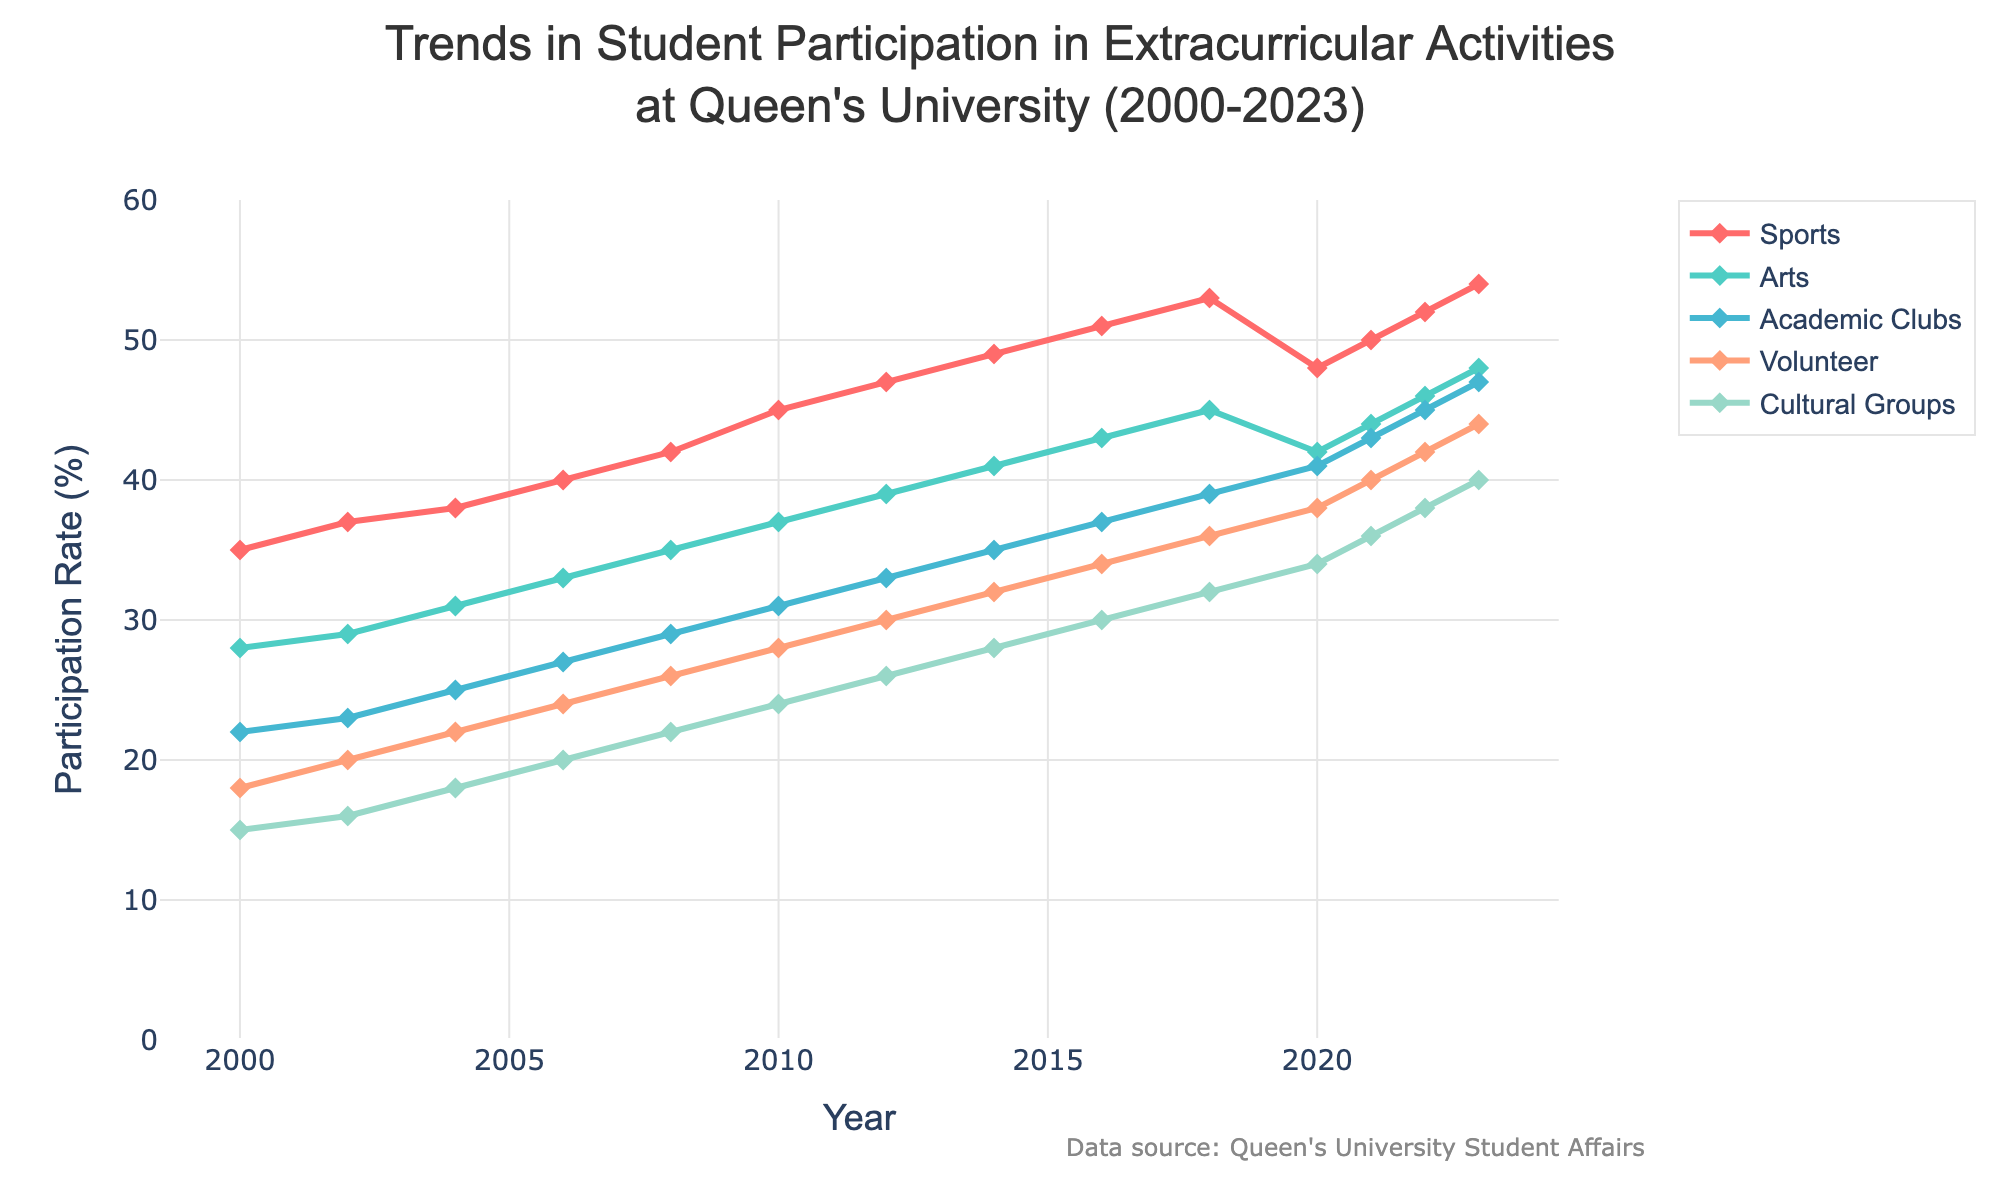What is the overall trend in student participation in sports from 2000 to 2023? Observing the graph, the trend line for sports participation generally increases from 35% in 2000 to 54% in 2023. This steady increase indicates a growing interest in sports among students over the years.
Answer: Increasing Which activity saw the highest participation rate in 2023? By looking at the endpoint of each trend line in 2023, sports have the highest participation rate at 54%, compared to arts, academic clubs, volunteer, and cultural groups.
Answer: Sports How did the participation rate in academic clubs change between 2010 and 2023? In 2010, the participation rate for academic clubs was 31%. By 2023, it had increased to 47%. Subtracting these values gives us an increase of 16 percentage points over this period.
Answer: Increased by 16 percentage points Compare the trends in volunteer activities and cultural groups from 2000 to 2023. Which had a steeper increase? From 2000 to 2023, the participation rate in volunteer activities increased from 18% to 44%, showing a rise of 26 percentage points. For cultural groups, it increased from 15% to 40%, an increase of 25 percentage points. The trend for volunteer activities had a slightly steeper increase by 1 percentage point.
Answer: Volunteer activities Which two activities had the most similar participation rates in 2020, and what were those rates? In 2020, the graph shows that academic clubs had a participation rate of 41% and volunteer activities had a rate of 38%. These two activities have the most similar rates among the categories listed.
Answer: Academic clubs (41%) and Volunteer activities (38%) What is the average participation rate for arts between 2000 and 2023? To find the average, sum the participation rates from 2000 to 2023: (28+29+31+33+35+37+39+41+43+45+42+44+46+48) = 581. There are 14 data points, so the average is 581 / 14 ≈ 41.5%.
Answer: Approximately 41.5% Between which consecutive years did sports see the biggest increase in participation? By observing the increments in sports participation, the biggest increase occurred between 2008 (42%) and 2010 (45%), a jump of 3 percentage points.
Answer: 2008 to 2010 How did the participation in cultural groups change in the last three years (2021-2023)? Analyzing the trend line for cultural groups from 2021 to 2023 shows participation rates of 36%, 38%, and 40%, respectively. This indicates a steady increase of 2 percentage points each year.
Answer: Increased steadily by 2 percentage points each year 